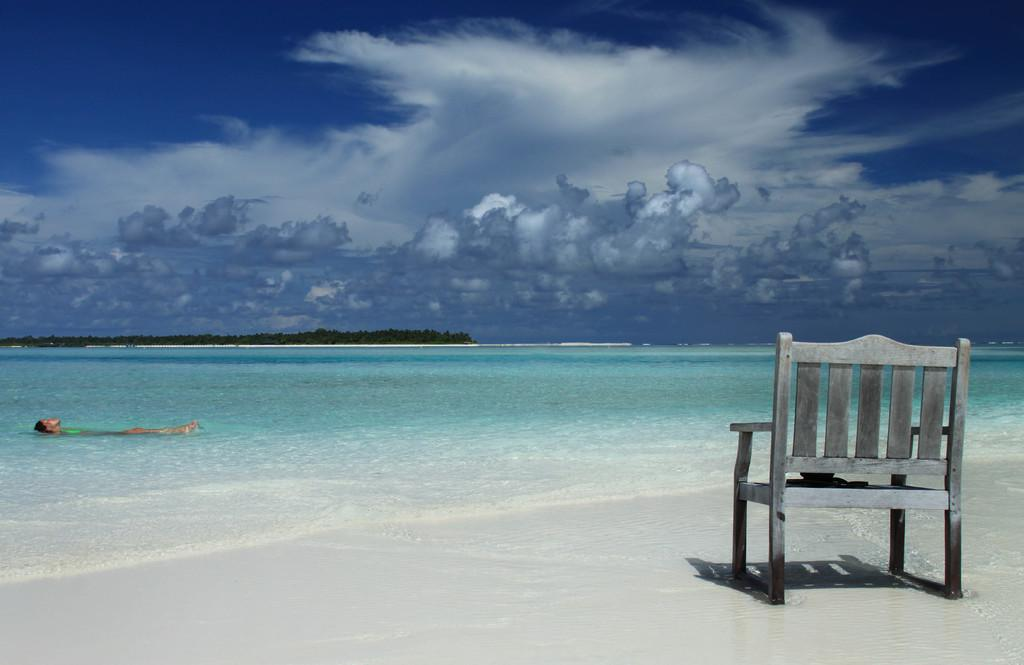What object is located on the right side of the image? There is a chair on the right side of the image. Where is the chair situated? The chair is on the sea shore. What activity is being performed by the person in the image? There is a person swimming in the water on the left side of the image. What type of vegetation can be seen in the background of the image? There are trees in the background of the image. How would you describe the weather based on the sky in the image? The sky is cloudy in the background of the image, suggesting a potentially overcast or cloudy day. Can you see any wings on the person swimming in the image? There are no wings visible on the person swimming in the image. What type of glass object is present on the sea shore in the image? There is no glass object present on the sea shore in the image. 